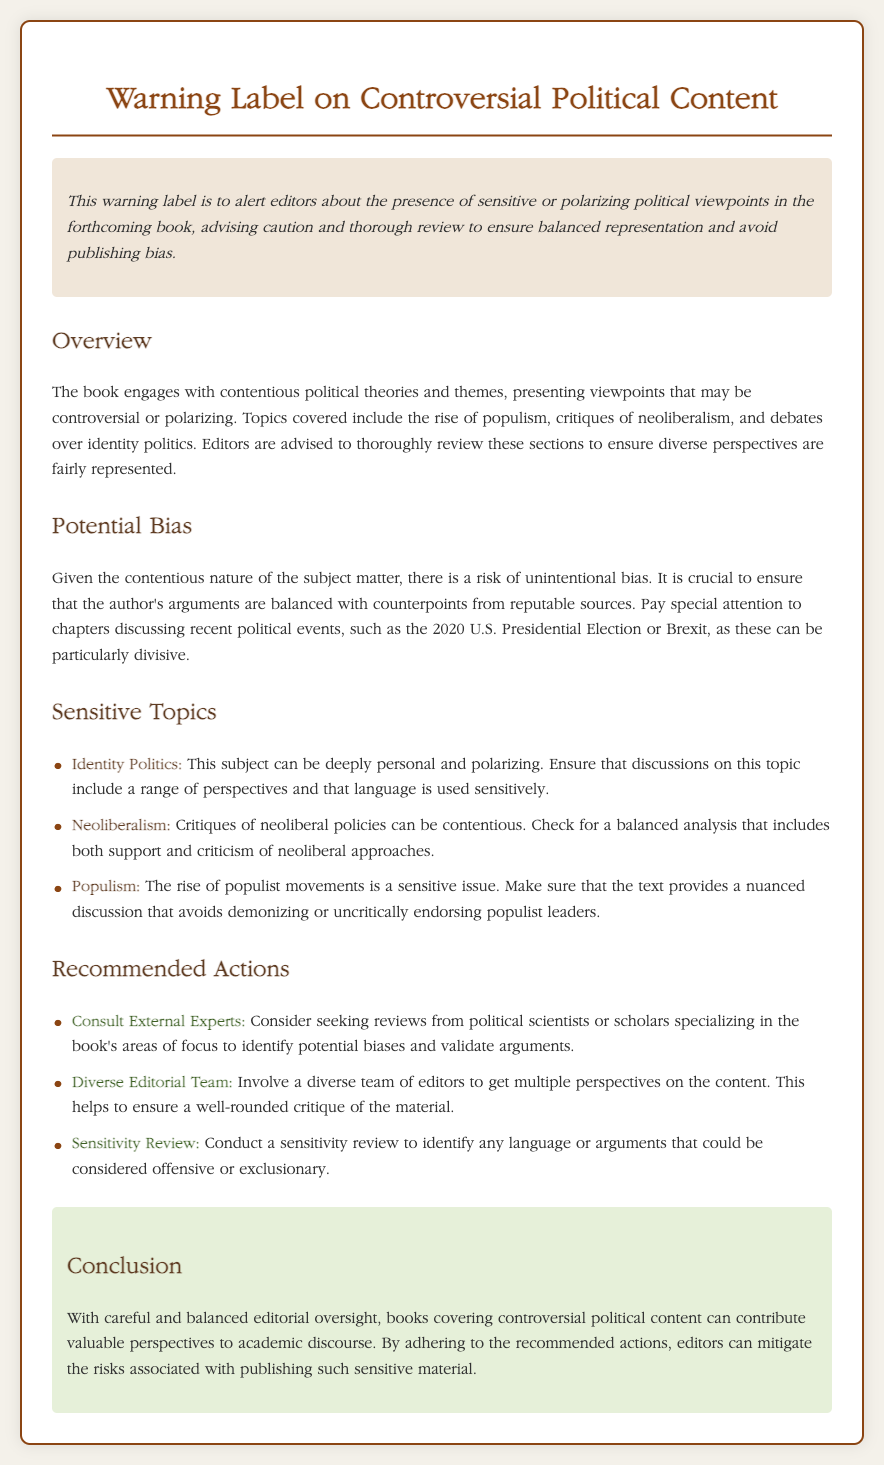What is the title of the document? The title of the document is indicated in the heading element of the document.
Answer: Warning Label on Controversial Political Content What is the main purpose of the warning label? The main purpose is to alert editors about the presence of sensitive or polarizing political viewpoints.
Answer: To alert editors about sensitive or polarizing political viewpoints Which section provides an overview of the book? The section that provides an overview is specifically labeled as "Overview".
Answer: Overview What are editors advised to review thoroughly? The editors are advised to review sections that may contain contentious political theories and themes.
Answer: Sections with contentious political theories and themes Name one sensitive topic discussed in the document. The document lists multiple sensitive topics including identity politics, neoliberalism, and populism.
Answer: Identity Politics What does the document suggest doing to ensure a balanced representation? The document suggests involving a diverse team of editors to provide multiple perspectives on the content.
Answer: Involve a diverse team of editors Which event does the document highlight as particularly divisive? The document highlights the 2020 U.S. Presidential Election as an event that can be particularly divisive.
Answer: The 2020 U.S. Presidential Election What recommended action involves seeking feedback? The action involving seeking feedback is to consult external experts in the relevant fields.
Answer: Consult External Experts What is the background color used for the conclusion section? The background color for the conclusion section is specifically mentioned in the document’s styling.
Answer: #e6f0d9 